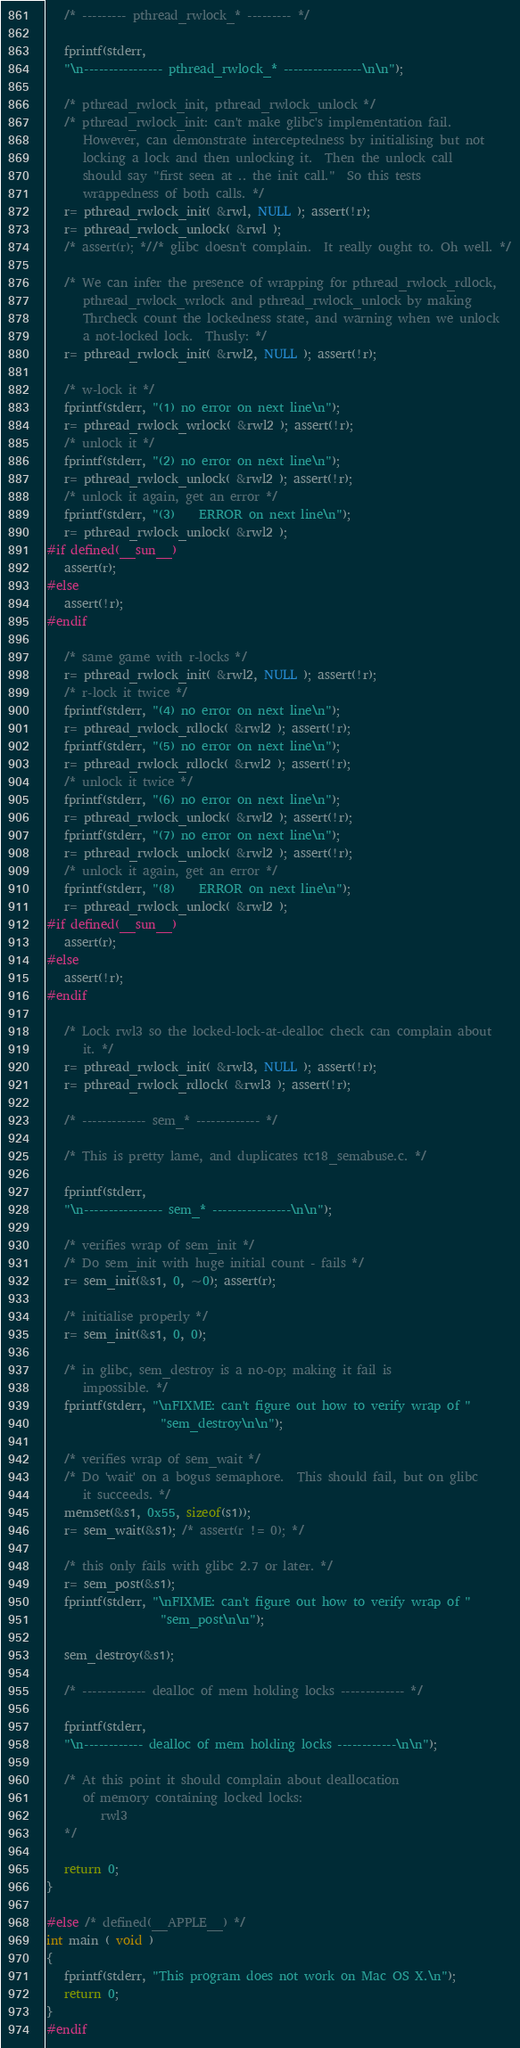Convert code to text. <code><loc_0><loc_0><loc_500><loc_500><_C_>   /* --------- pthread_rwlock_* --------- */

   fprintf(stderr,
   "\n---------------- pthread_rwlock_* ----------------\n\n");

   /* pthread_rwlock_init, pthread_rwlock_unlock */
   /* pthread_rwlock_init: can't make glibc's implementation fail.
      However, can demonstrate interceptedness by initialising but not
      locking a lock and then unlocking it.  Then the unlock call
      should say "first seen at .. the init call."  So this tests
      wrappedness of both calls. */
   r= pthread_rwlock_init( &rwl, NULL ); assert(!r);
   r= pthread_rwlock_unlock( &rwl ); 
   /* assert(r); *//* glibc doesn't complain.  It really ought to. Oh well. */

   /* We can infer the presence of wrapping for pthread_rwlock_rdlock,
      pthread_rwlock_wrlock and pthread_rwlock_unlock by making
      Thrcheck count the lockedness state, and warning when we unlock
      a not-locked lock.  Thusly: */
   r= pthread_rwlock_init( &rwl2, NULL ); assert(!r);

   /* w-lock it */
   fprintf(stderr, "(1) no error on next line\n");
   r= pthread_rwlock_wrlock( &rwl2 ); assert(!r);
   /* unlock it */
   fprintf(stderr, "(2) no error on next line\n");
   r= pthread_rwlock_unlock( &rwl2 ); assert(!r);
   /* unlock it again, get an error */
   fprintf(stderr, "(3)    ERROR on next line\n");
   r= pthread_rwlock_unlock( &rwl2 );
#if defined(__sun__)
   assert(r);
#else
   assert(!r);
#endif

   /* same game with r-locks */
   r= pthread_rwlock_init( &rwl2, NULL ); assert(!r);
   /* r-lock it twice */
   fprintf(stderr, "(4) no error on next line\n");
   r= pthread_rwlock_rdlock( &rwl2 ); assert(!r);
   fprintf(stderr, "(5) no error on next line\n");
   r= pthread_rwlock_rdlock( &rwl2 ); assert(!r);
   /* unlock it twice */
   fprintf(stderr, "(6) no error on next line\n");
   r= pthread_rwlock_unlock( &rwl2 ); assert(!r);
   fprintf(stderr, "(7) no error on next line\n");
   r= pthread_rwlock_unlock( &rwl2 ); assert(!r);
   /* unlock it again, get an error */
   fprintf(stderr, "(8)    ERROR on next line\n");
   r= pthread_rwlock_unlock( &rwl2 );
#if defined(__sun__)
   assert(r);
#else
   assert(!r);
#endif

   /* Lock rwl3 so the locked-lock-at-dealloc check can complain about
      it. */
   r= pthread_rwlock_init( &rwl3, NULL ); assert(!r);
   r= pthread_rwlock_rdlock( &rwl3 ); assert(!r);

   /* ------------- sem_* ------------- */

   /* This is pretty lame, and duplicates tc18_semabuse.c. */

   fprintf(stderr,
   "\n---------------- sem_* ----------------\n\n");

   /* verifies wrap of sem_init */
   /* Do sem_init with huge initial count - fails */
   r= sem_init(&s1, 0, ~0); assert(r);

   /* initialise properly */
   r= sem_init(&s1, 0, 0);

   /* in glibc, sem_destroy is a no-op; making it fail is
      impossible. */
   fprintf(stderr, "\nFIXME: can't figure out how to verify wrap of "
                   "sem_destroy\n\n");

   /* verifies wrap of sem_wait */
   /* Do 'wait' on a bogus semaphore.  This should fail, but on glibc
      it succeeds. */
   memset(&s1, 0x55, sizeof(s1));
   r= sem_wait(&s1); /* assert(r != 0); */

   /* this only fails with glibc 2.7 or later. */
   r= sem_post(&s1);
   fprintf(stderr, "\nFIXME: can't figure out how to verify wrap of "
                   "sem_post\n\n");

   sem_destroy(&s1);

   /* ------------- dealloc of mem holding locks ------------- */

   fprintf(stderr,
   "\n------------ dealloc of mem holding locks ------------\n\n");

   /* At this point it should complain about deallocation
      of memory containing locked locks:
         rwl3
   */

   return 0;
}

#else /* defined(__APPLE__) */
int main ( void )
{
   fprintf(stderr, "This program does not work on Mac OS X.\n");
   return 0;
}
#endif
</code> 